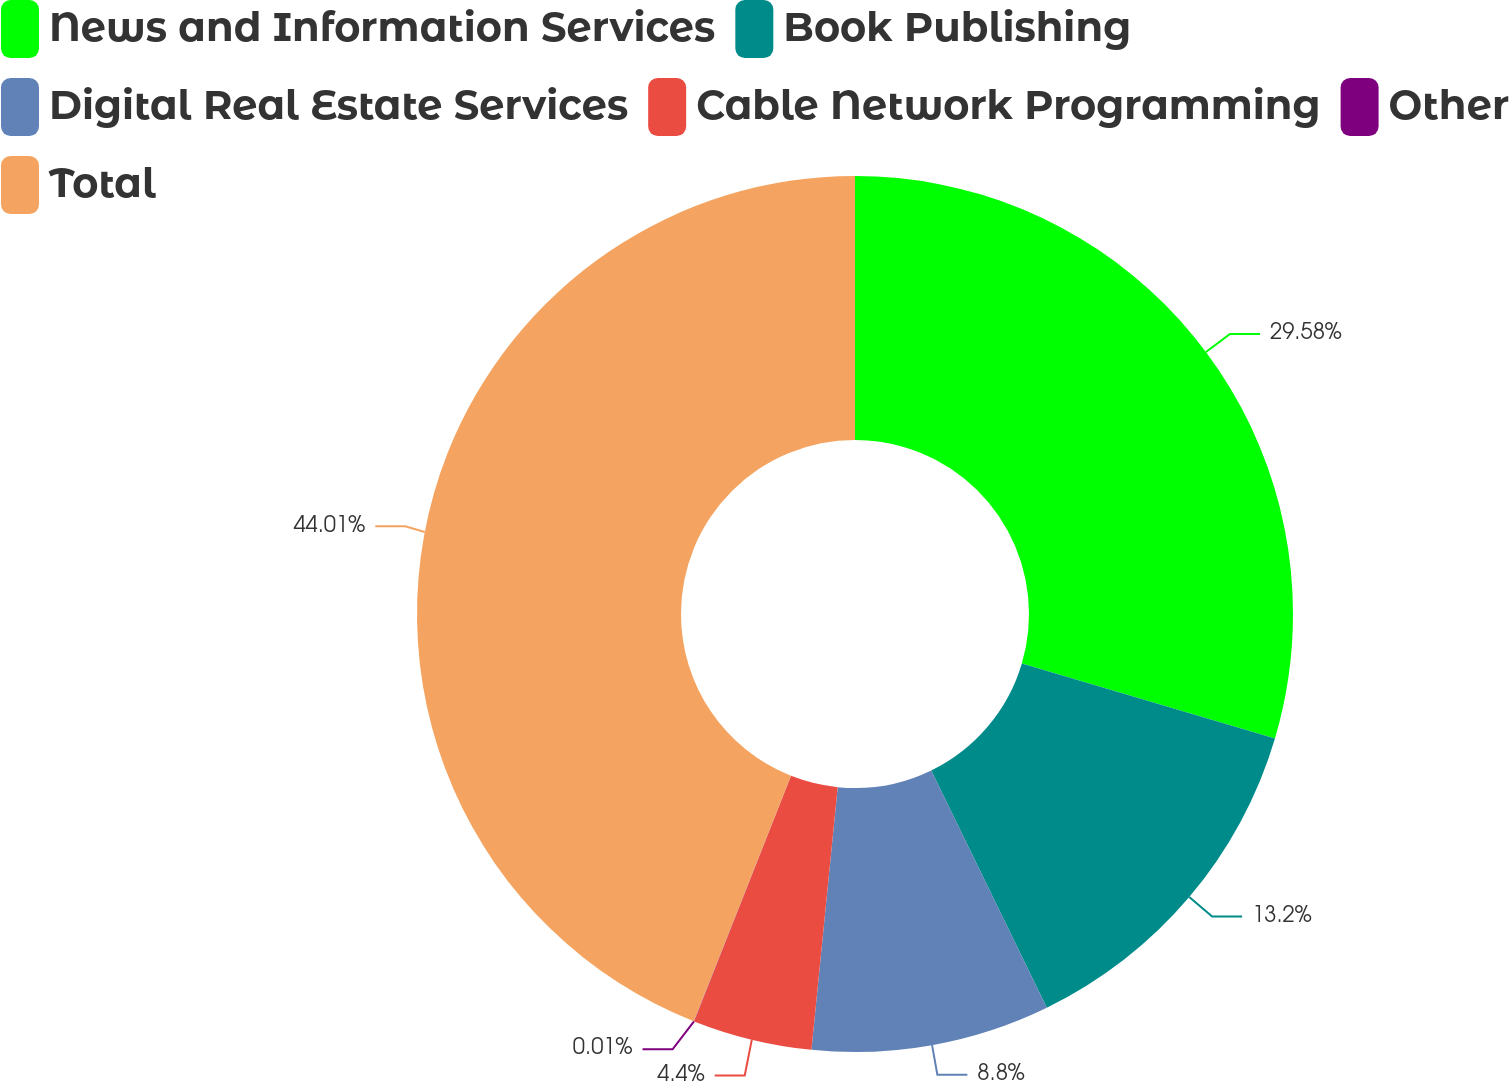<chart> <loc_0><loc_0><loc_500><loc_500><pie_chart><fcel>News and Information Services<fcel>Book Publishing<fcel>Digital Real Estate Services<fcel>Cable Network Programming<fcel>Other<fcel>Total<nl><fcel>29.58%<fcel>13.2%<fcel>8.8%<fcel>4.4%<fcel>0.01%<fcel>44.0%<nl></chart> 